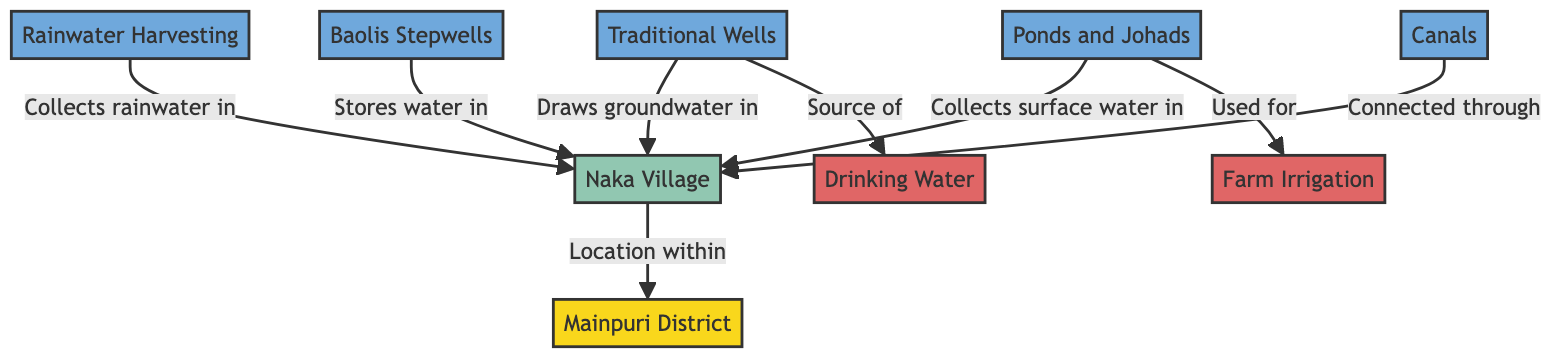What is the primary location in the diagram? The primary location in the diagram is "Mainpuri District," which is the first node that encompasses the entire structure of water management systems and distribution.
Answer: Mainpuri District How many types of water sources are identified in the diagram? The diagram lists five distinct types of water sources: Rainwater Harvesting, Traditional Wells, Baolis Stepwells, Ponds and Johads, and Canals, making a total of five.
Answer: 5 Which water source is connected through Naka Village? The diagram indicates "Canals" as the water source connected through Naka Village, as shown by the direct link to Naka Village.
Answer: Canals Which water usage is directly derived from Traditional Wells? The diagram specifies that Traditional Wells are a source of "Drinking Water," indicating a direct relationship between them.
Answer: Drinking Water What is collected by Ponds and Johads in Naka Village? According to the diagram, Ponds and Johads collect "surface water" as indicated by the connection labeled with their function in the context of water management.
Answer: Surface water Which water source is used primarily for farm irrigation? The diagram connects "Ponds and Johads" to the usage of "Farm Irrigation," indicating that they serve this particular purpose within local agriculture.
Answer: Farm Irrigation How many edges connect Naka Village to the water sources in the diagram? There are four edges connecting Naka Village to the various water sources: Rainwater Harvesting, Traditional Wells, Baolis Stepwells, and Ponds and Johads, making it a total of four edges.
Answer: 4 What type of diagram is represented? The diagram is a "Textbook Diagram," as indicated in the initial context, which characterizes its informative structure.
Answer: Textbook Diagram What connects Traditional Wells to Naka Village? The connection line labeled "Draws groundwater in" details that Traditional Wells are linked through the process of groundwater extraction to Naka Village.
Answer: Draws groundwater in 